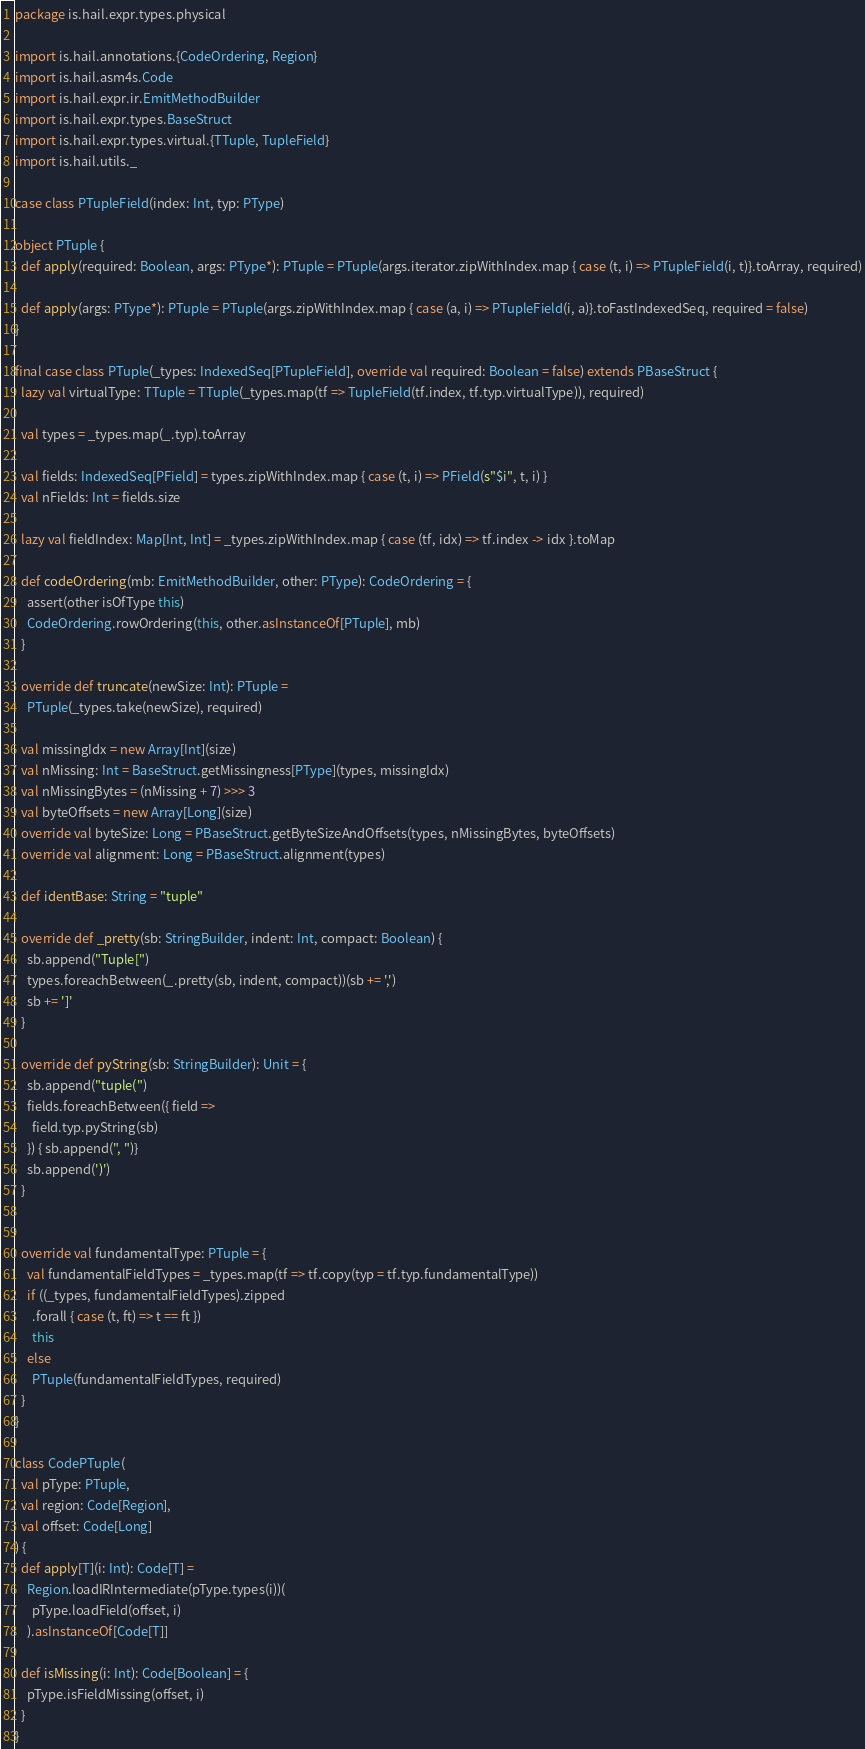<code> <loc_0><loc_0><loc_500><loc_500><_Scala_>package is.hail.expr.types.physical

import is.hail.annotations.{CodeOrdering, Region}
import is.hail.asm4s.Code
import is.hail.expr.ir.EmitMethodBuilder
import is.hail.expr.types.BaseStruct
import is.hail.expr.types.virtual.{TTuple, TupleField}
import is.hail.utils._

case class PTupleField(index: Int, typ: PType)

object PTuple {
  def apply(required: Boolean, args: PType*): PTuple = PTuple(args.iterator.zipWithIndex.map { case (t, i) => PTupleField(i, t)}.toArray, required)

  def apply(args: PType*): PTuple = PTuple(args.zipWithIndex.map { case (a, i) => PTupleField(i, a)}.toFastIndexedSeq, required = false)
}

final case class PTuple(_types: IndexedSeq[PTupleField], override val required: Boolean = false) extends PBaseStruct {
  lazy val virtualType: TTuple = TTuple(_types.map(tf => TupleField(tf.index, tf.typ.virtualType)), required)

  val types = _types.map(_.typ).toArray

  val fields: IndexedSeq[PField] = types.zipWithIndex.map { case (t, i) => PField(s"$i", t, i) }
  val nFields: Int = fields.size

  lazy val fieldIndex: Map[Int, Int] = _types.zipWithIndex.map { case (tf, idx) => tf.index -> idx }.toMap

  def codeOrdering(mb: EmitMethodBuilder, other: PType): CodeOrdering = {
    assert(other isOfType this)
    CodeOrdering.rowOrdering(this, other.asInstanceOf[PTuple], mb)
  }

  override def truncate(newSize: Int): PTuple =
    PTuple(_types.take(newSize), required)

  val missingIdx = new Array[Int](size)
  val nMissing: Int = BaseStruct.getMissingness[PType](types, missingIdx)
  val nMissingBytes = (nMissing + 7) >>> 3
  val byteOffsets = new Array[Long](size)
  override val byteSize: Long = PBaseStruct.getByteSizeAndOffsets(types, nMissingBytes, byteOffsets)
  override val alignment: Long = PBaseStruct.alignment(types)

  def identBase: String = "tuple"

  override def _pretty(sb: StringBuilder, indent: Int, compact: Boolean) {
    sb.append("Tuple[")
    types.foreachBetween(_.pretty(sb, indent, compact))(sb += ',')
    sb += ']'
  }

  override def pyString(sb: StringBuilder): Unit = {
    sb.append("tuple(")
    fields.foreachBetween({ field =>
      field.typ.pyString(sb)
    }) { sb.append(", ")}
    sb.append(')')
  }


  override val fundamentalType: PTuple = {
    val fundamentalFieldTypes = _types.map(tf => tf.copy(typ = tf.typ.fundamentalType))
    if ((_types, fundamentalFieldTypes).zipped
      .forall { case (t, ft) => t == ft })
      this
    else
      PTuple(fundamentalFieldTypes, required)
  }
}

class CodePTuple(
  val pType: PTuple,
  val region: Code[Region],
  val offset: Code[Long]
) {
  def apply[T](i: Int): Code[T] =
    Region.loadIRIntermediate(pType.types(i))(
      pType.loadField(offset, i)
    ).asInstanceOf[Code[T]]

  def isMissing(i: Int): Code[Boolean] = {
    pType.isFieldMissing(offset, i)
  }
}</code> 